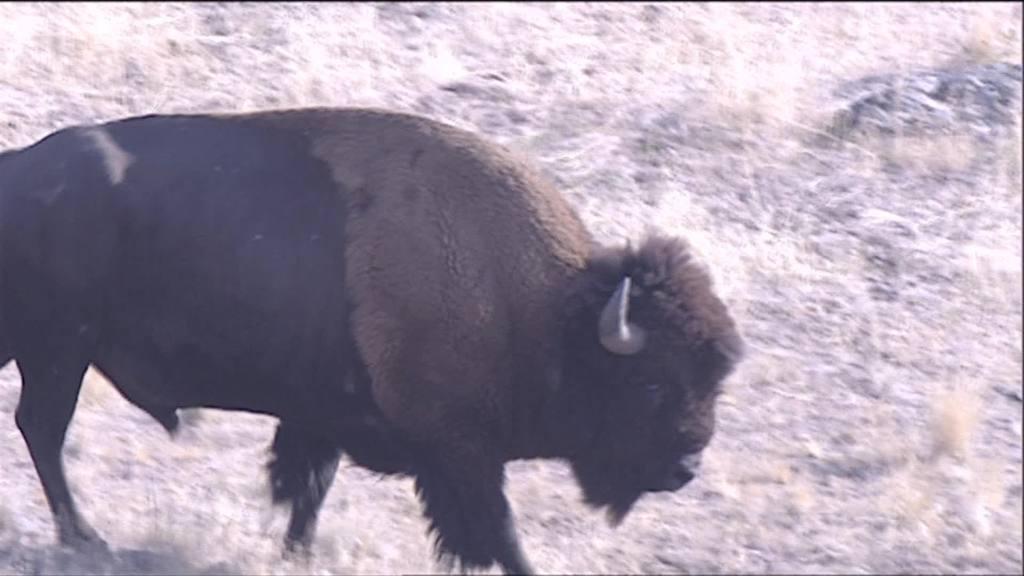Can you describe this image briefly? In this image I can see an animal which is in black and brown color. To the side of an animal I can see the dried trees. 